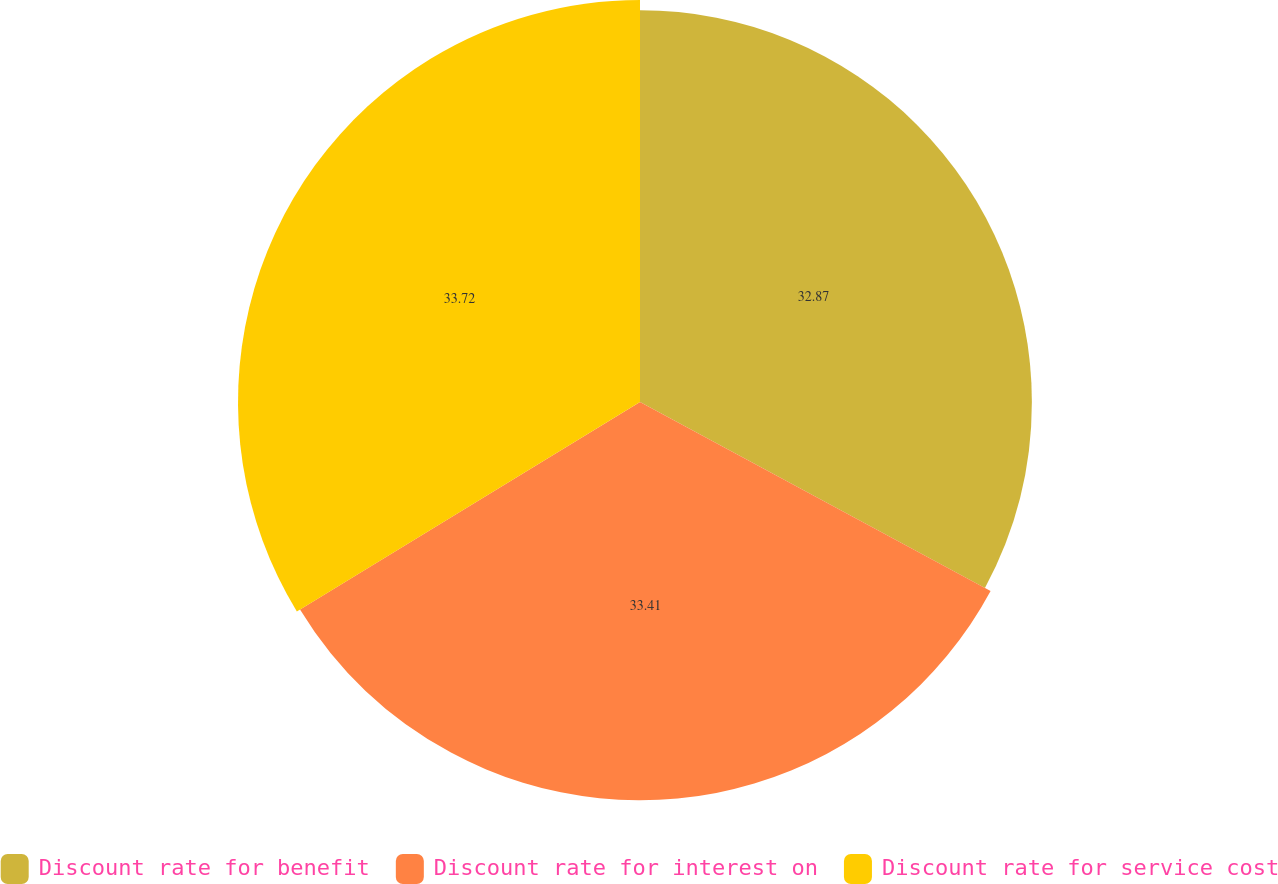<chart> <loc_0><loc_0><loc_500><loc_500><pie_chart><fcel>Discount rate for benefit<fcel>Discount rate for interest on<fcel>Discount rate for service cost<nl><fcel>32.87%<fcel>33.41%<fcel>33.72%<nl></chart> 